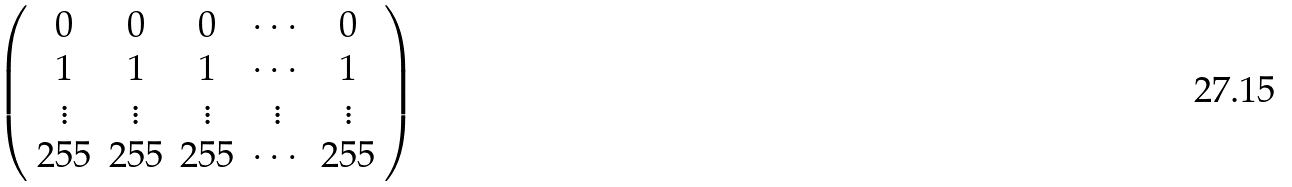<formula> <loc_0><loc_0><loc_500><loc_500>\left ( \begin{array} { c c c c c } 0 & 0 & 0 & \cdots & 0 \\ 1 & 1 & 1 & \cdots & 1 \\ \vdots & \vdots & \vdots & \vdots & \vdots \\ 2 5 5 & 2 5 5 & 2 5 5 & \cdots & 2 5 5 \\ \end{array} \right )</formula> 